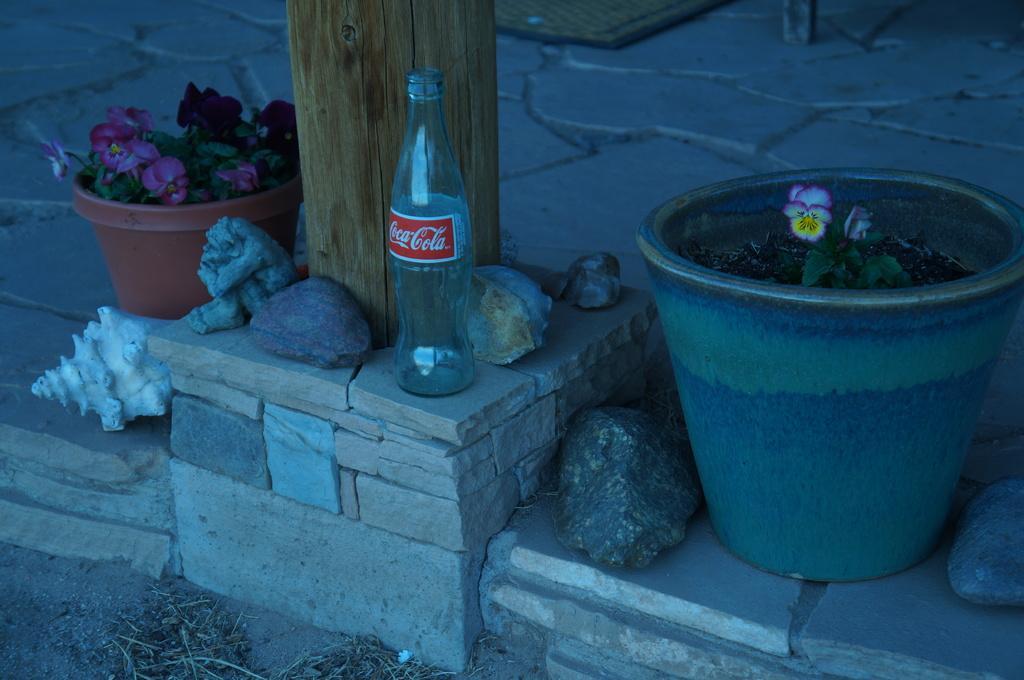Can you describe this image briefly? In this picture there is an empty glass bottle placed on a stone hedge , beside that we also observe few small stones and there is a white shell beside it. There are two flower pots on both the sides of an image. A wooden pole behind the glass bottle. 